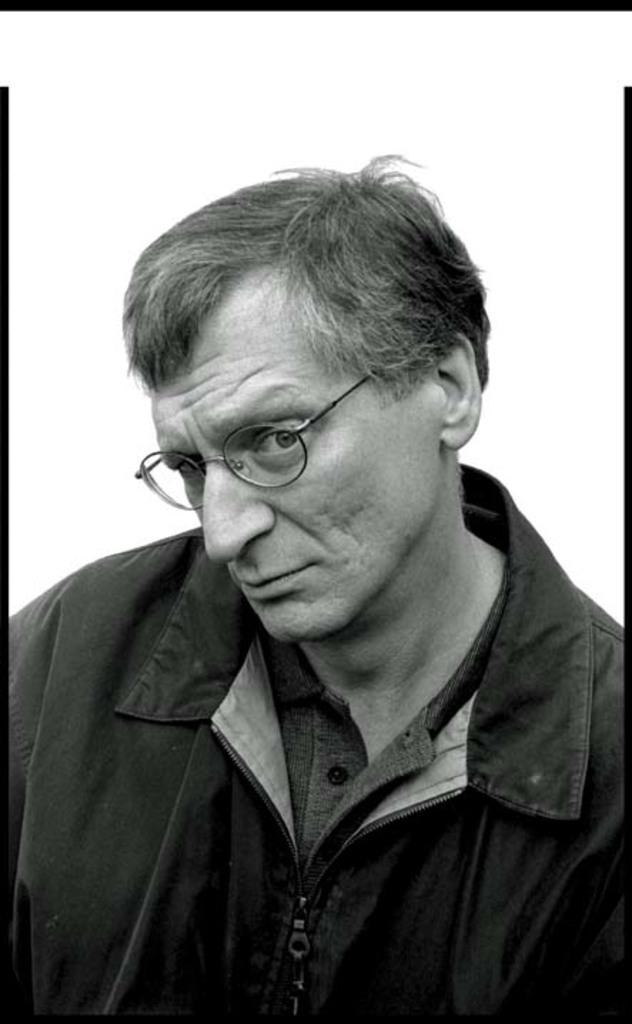Could you give a brief overview of what you see in this image? In this picture we can see a man. He wore spectacles. This is a black and white picture. 